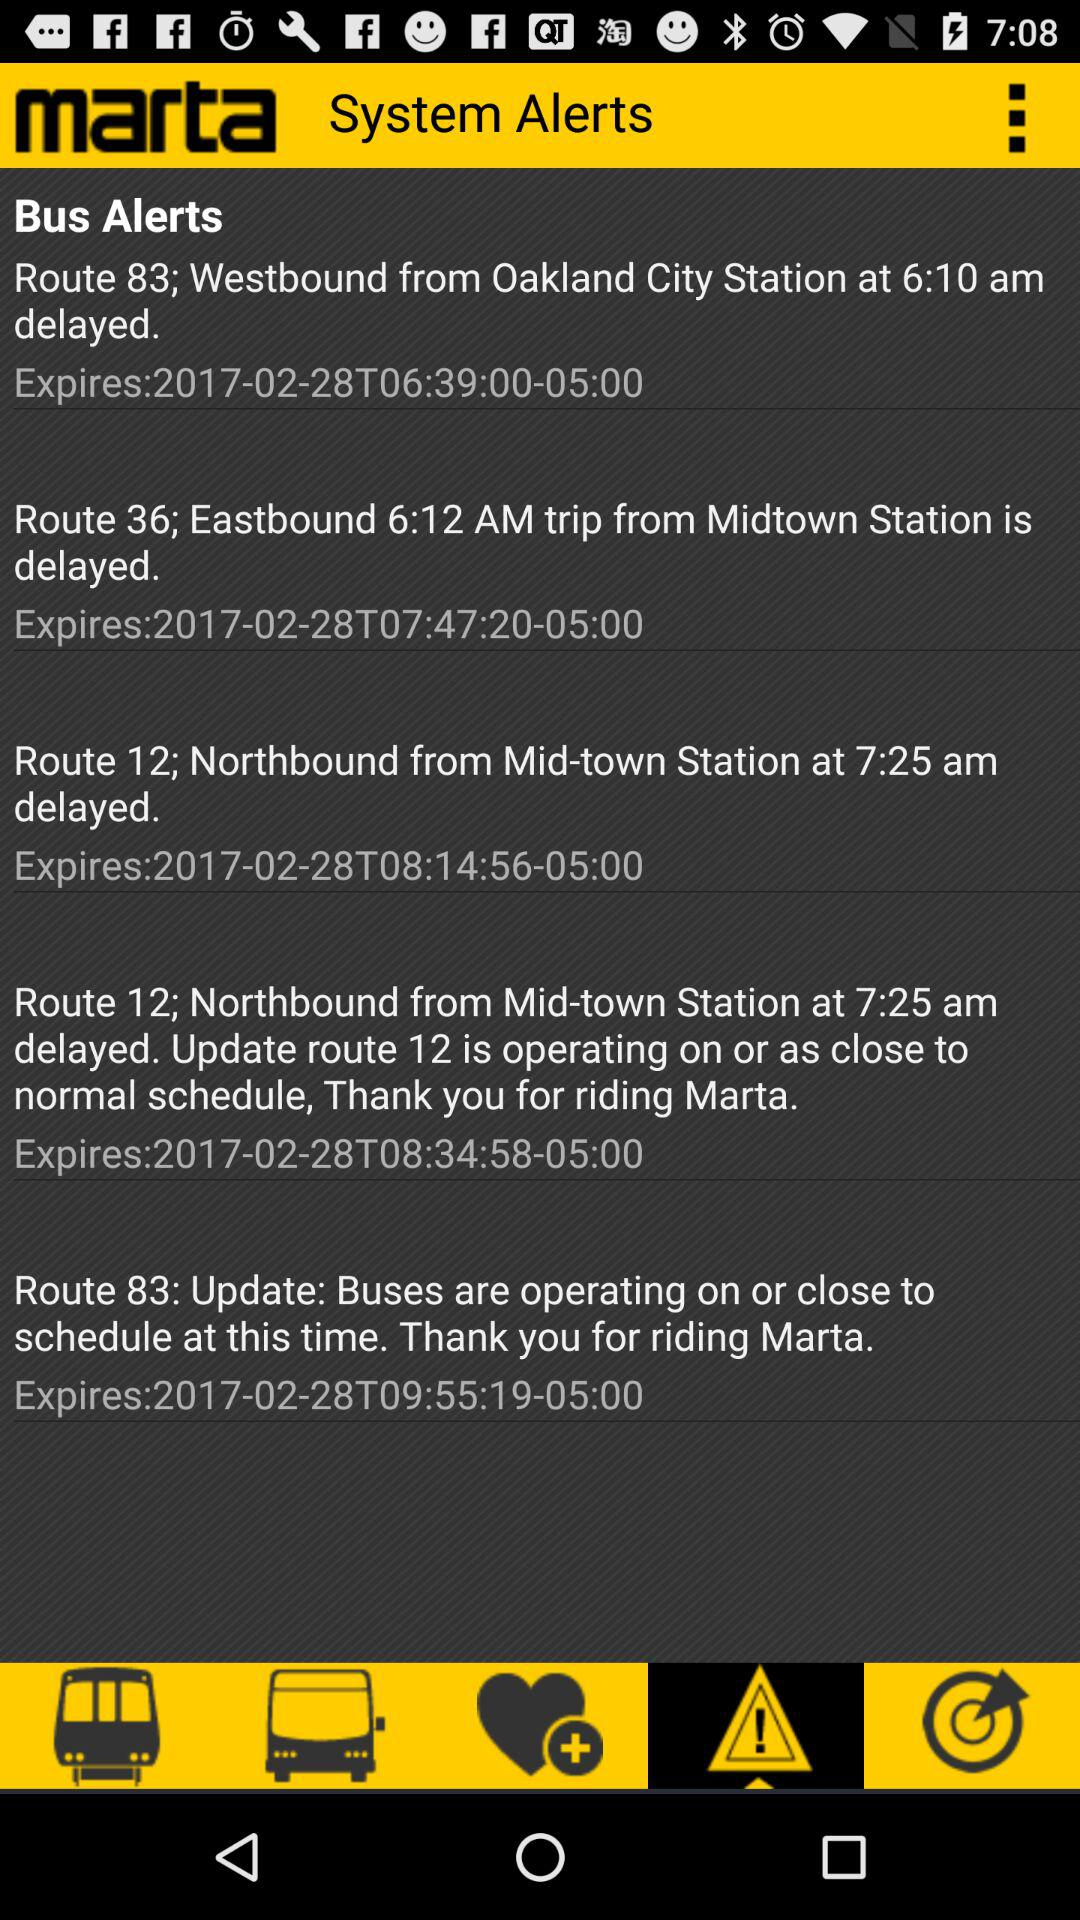What is the name of the application? The name of the application is "marta". 